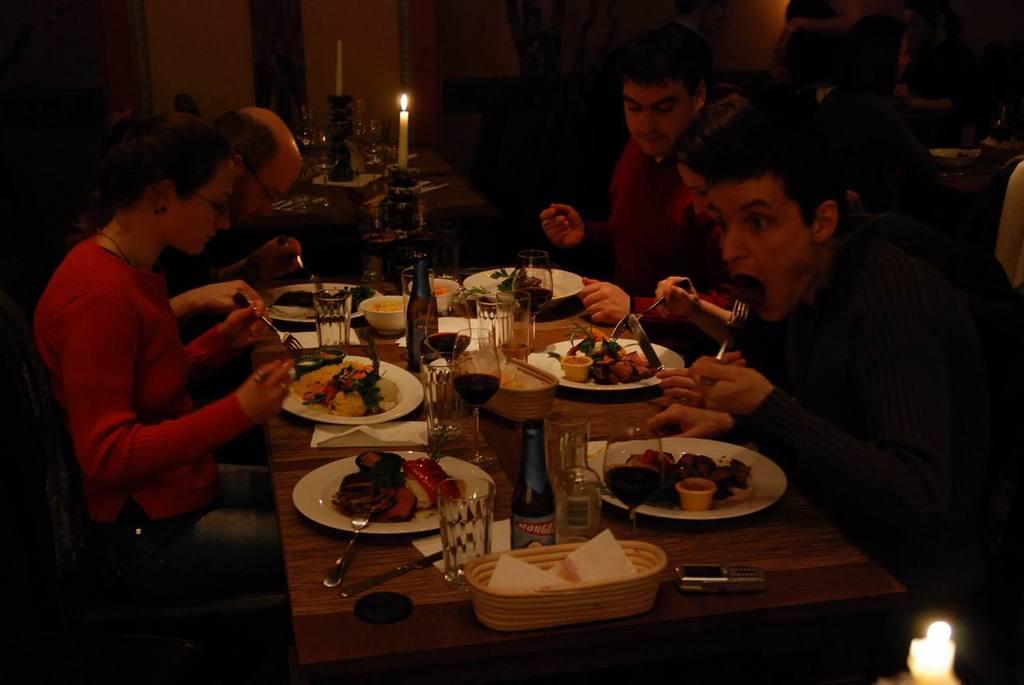In one or two sentences, can you explain what this image depicts? It is a restaurant there is a table on the table lot of food, beside the table there are some people sitting and having their food on the other table there is a candle,in the background there is a wall. 